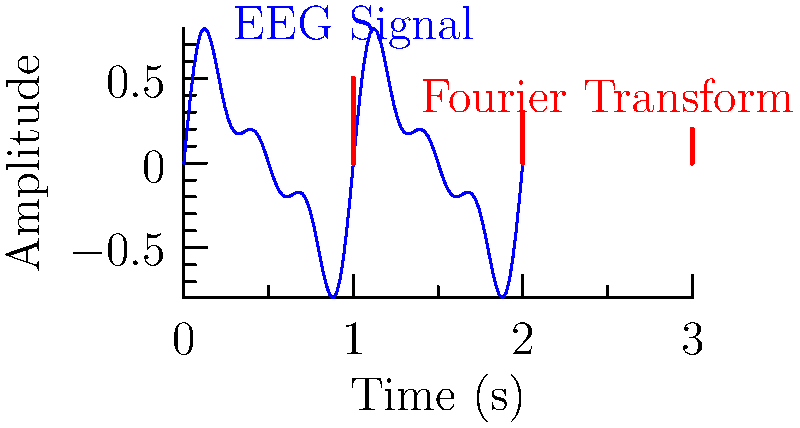An EEG signal is composed of three sinusoidal components with frequencies of 1 Hz, 2 Hz, and 3 Hz. The amplitudes of these components are 0.5, 0.3, and 0.2, respectively. Using the Fourier transform, what is the dominant frequency in this EEG signal, and how does this relate to brain wave classifications? To solve this problem, we need to follow these steps:

1. Understand the components of the EEG signal:
   - 1 Hz component with amplitude 0.5
   - 2 Hz component with amplitude 0.3
   - 3 Hz component with amplitude 0.2

2. Identify the dominant frequency:
   The dominant frequency is the one with the highest amplitude. In this case, it's the 1 Hz component with an amplitude of 0.5.

3. Relate the dominant frequency to brain wave classifications:
   - Delta waves: 0.5-4 Hz
   - Theta waves: 4-8 Hz
   - Alpha waves: 8-13 Hz
   - Beta waves: 13-30 Hz
   - Gamma waves: >30 Hz

The dominant frequency of 1 Hz falls within the delta wave range (0.5-4 Hz).

4. Interpret the results:
   Delta waves are typically associated with deep sleep and unconsciousness. However, they can also be present during waking states, especially in the frontal regions of the brain, and are linked to attention and certain cognitive processes.

5. Understand the importance of Fourier transforms in EEG analysis:
   Fourier transforms allow us to decompose complex EEG signals into their constituent frequencies, enabling the identification and quantification of different brain wave patterns. This is crucial for understanding brain states and diagnosing neurological conditions.
Answer: 1 Hz (delta wave range) 